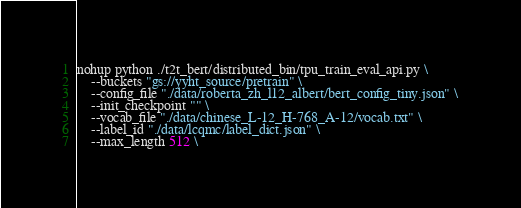Convert code to text. <code><loc_0><loc_0><loc_500><loc_500><_Bash_>nohup python ./t2t_bert/distributed_bin/tpu_train_eval_api.py \
	--buckets "gs://yyht_source/pretrain" \
	--config_file "./data/roberta_zh_l12_albert/bert_config_tiny.json" \
	--init_checkpoint "" \
	--vocab_file "./data/chinese_L-12_H-768_A-12/vocab.txt" \
	--label_id "./data/lcqmc/label_dict.json" \
	--max_length 512 \</code> 